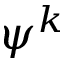Convert formula to latex. <formula><loc_0><loc_0><loc_500><loc_500>\psi ^ { k }</formula> 